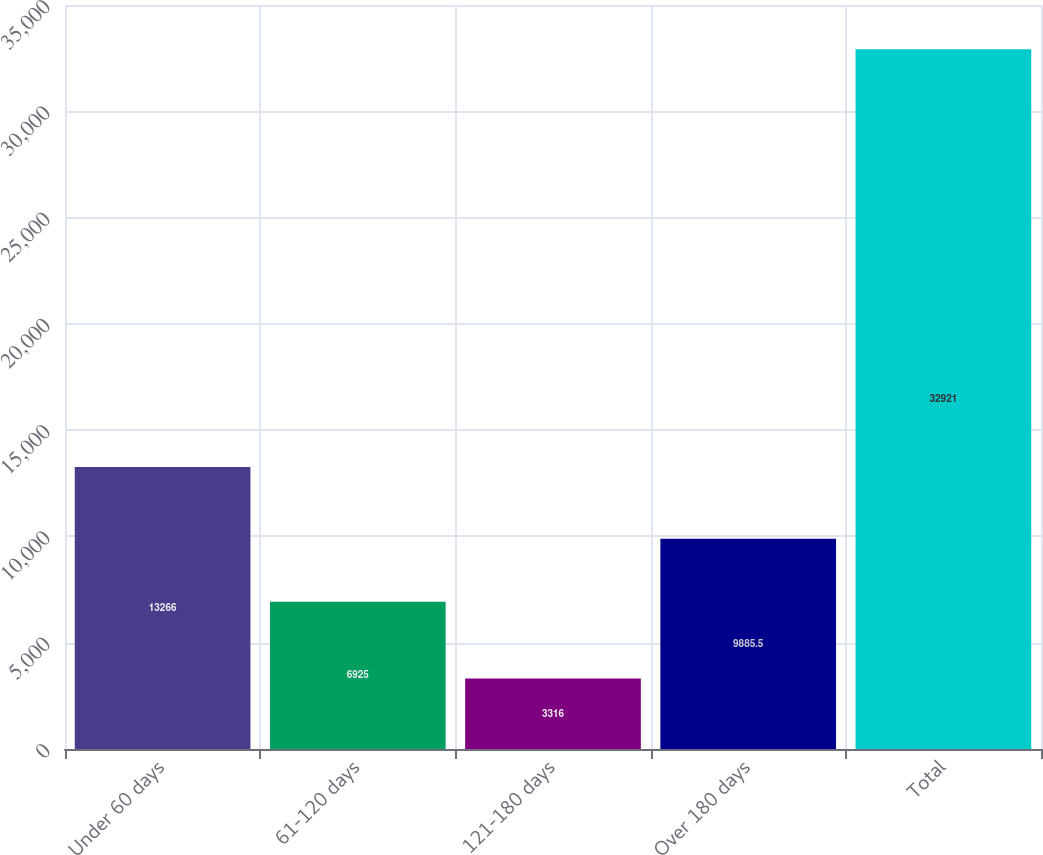Convert chart to OTSL. <chart><loc_0><loc_0><loc_500><loc_500><bar_chart><fcel>Under 60 days<fcel>61-120 days<fcel>121-180 days<fcel>Over 180 days<fcel>Total<nl><fcel>13266<fcel>6925<fcel>3316<fcel>9885.5<fcel>32921<nl></chart> 